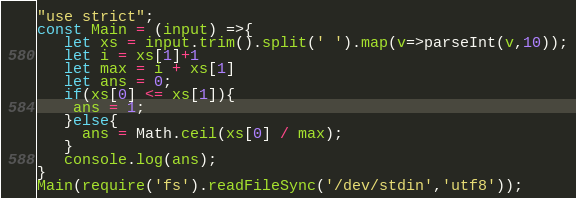Convert code to text. <code><loc_0><loc_0><loc_500><loc_500><_JavaScript_>"use strict";
const Main = (input) =>{
   let xs = input.trim().split(' ').map(v=>parseInt(v,10));
   let i = xs[1]+1
   let max = i + xs[1]
   let ans = 0;
   if(xs[0] <= xs[1]){
    ans = 1;
   }else{
     ans = Math.ceil(xs[0] / max);
   } 
   console.log(ans);   
}
Main(require('fs').readFileSync('/dev/stdin','utf8'));</code> 